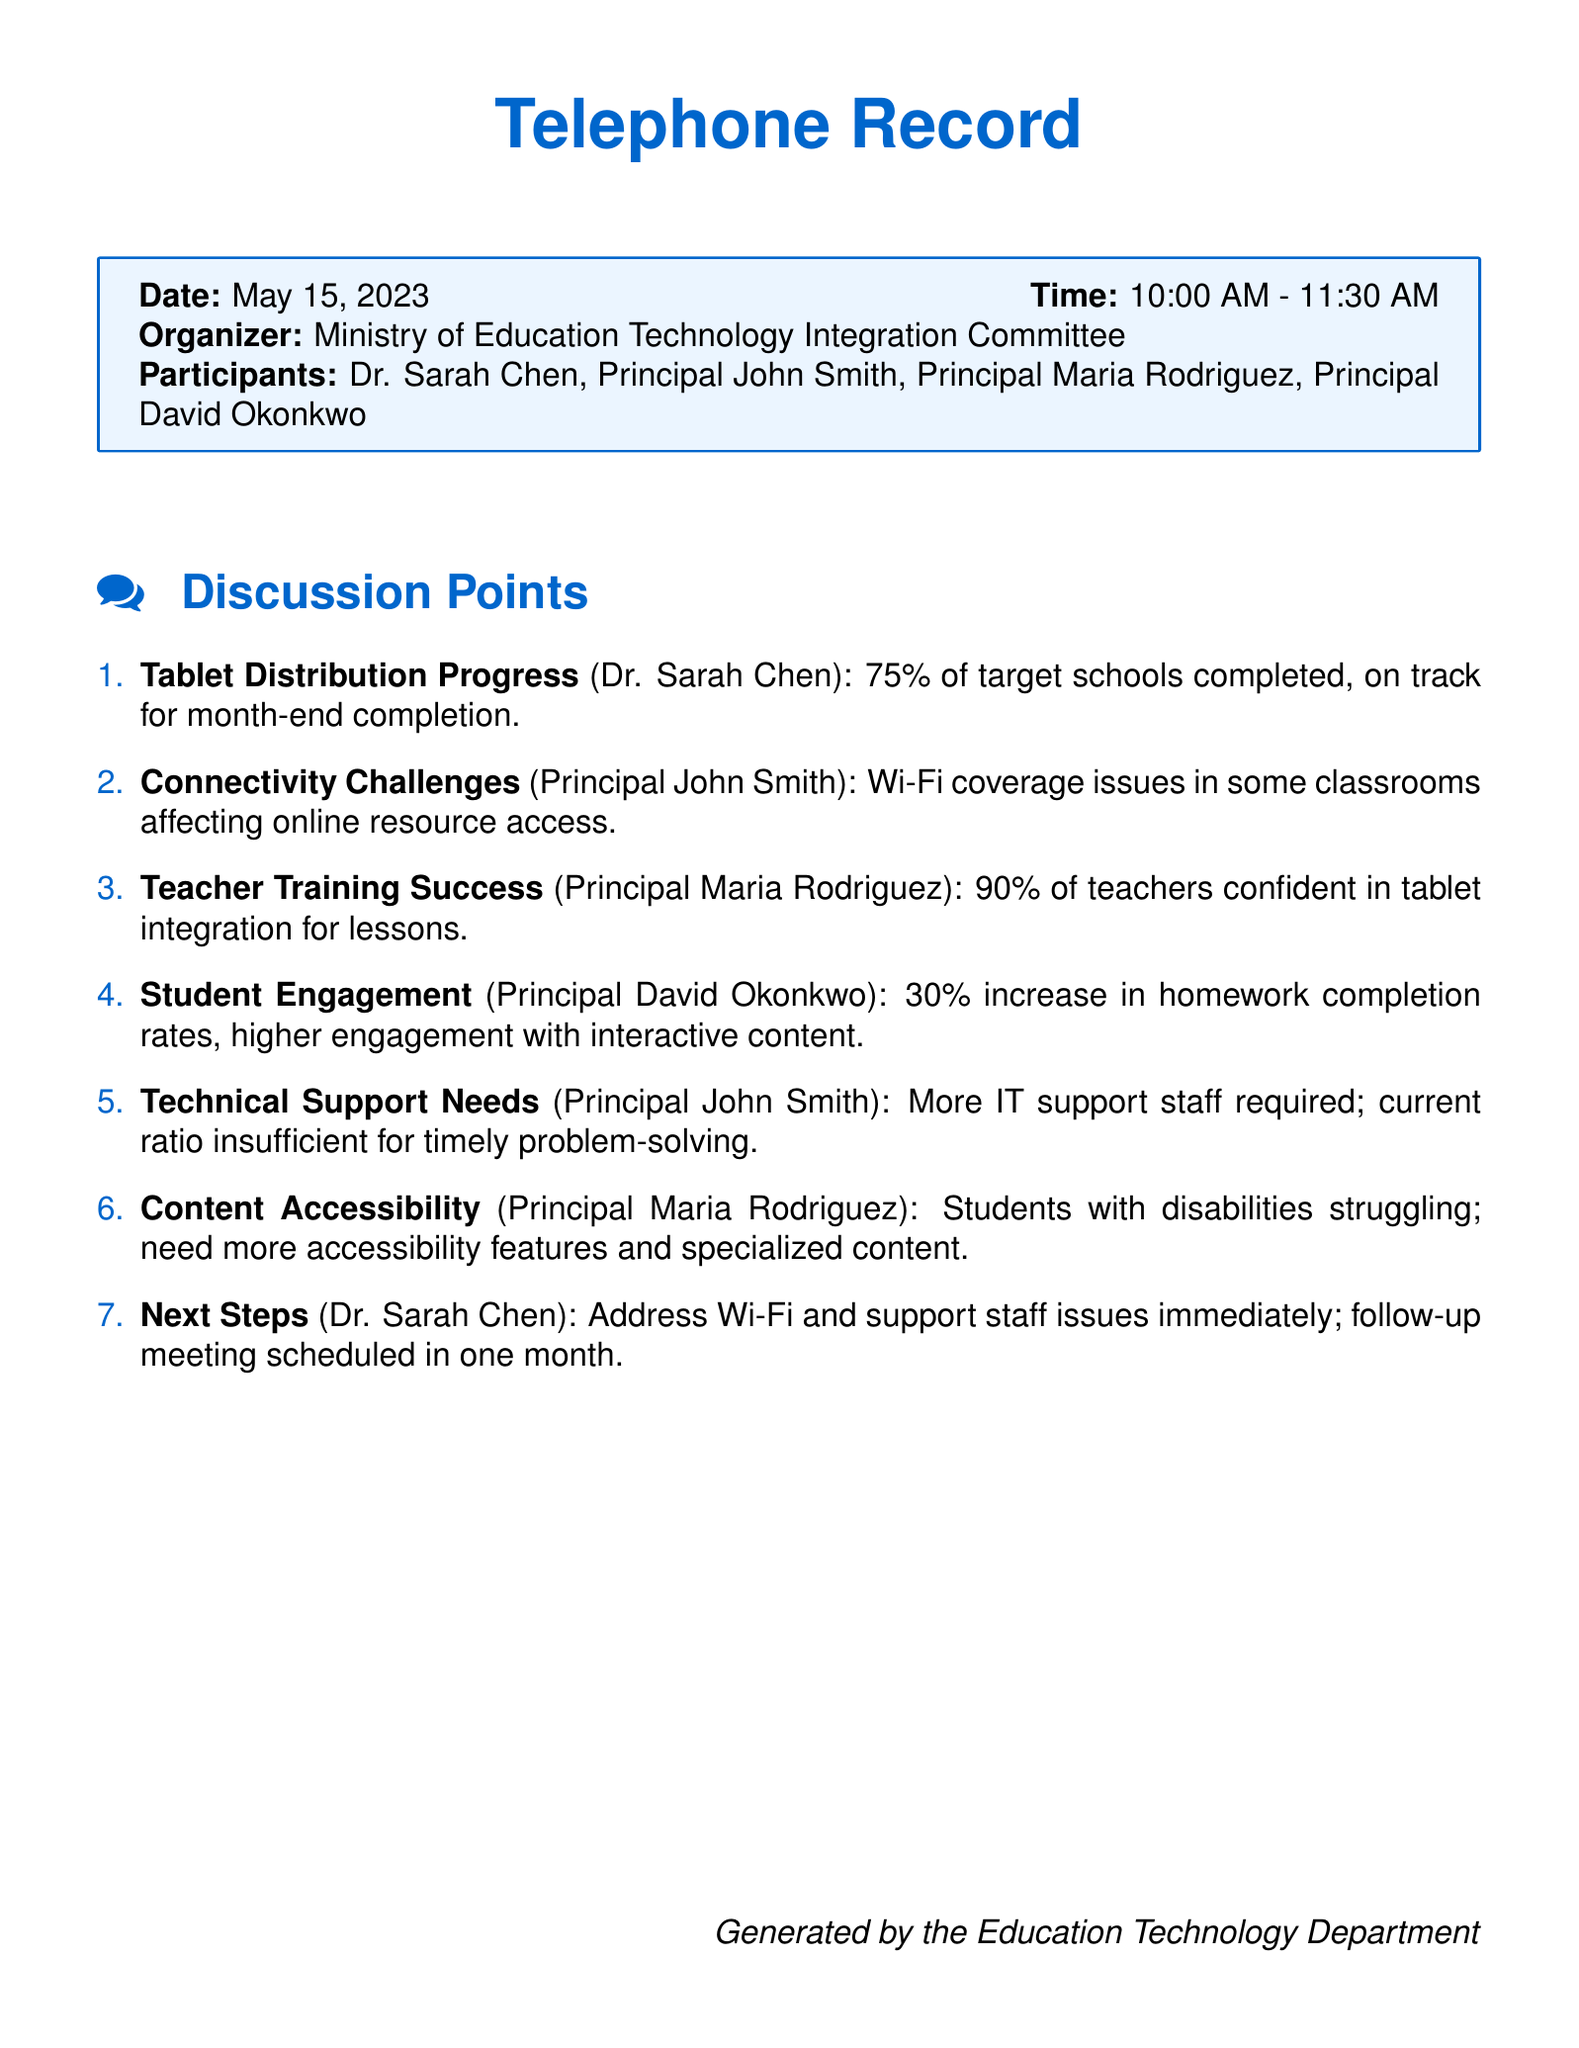What is the date of the teleconference? The date of the teleconference is listed at the beginning of the document.
Answer: May 15, 2023 Who organized the meeting? The organizer of the meeting is mentioned in the introductory section of the document.
Answer: Ministry of Education Technology Integration Committee What percentage of target schools completed the tablet distribution? The progress of tablet distribution is noted in the discussion points.
Answer: 75% What issue affects Wi-Fi coverage? The specific issue with Wi-Fi coverage is stated in Principal John Smith's comments.
Answer: Coverage issues in some classrooms What is the increase in homework completion rates? The details about student engagement are provided by Principal David Okonkwo in the discussion points.
Answer: 30% What is the teachers' confidence percentage in tablet integration? Principal Maria Rodriguez provides this figure in the context of teacher training success.
Answer: 90% What technical need was identified by Principal John Smith? The need for additional support staff is mentioned by Principal John Smith.
Answer: More IT support staff What is the next meeting's scheduling timeframe? The next steps include a follow-up meeting mentioned by Dr. Sarah Chen.
Answer: In one month 